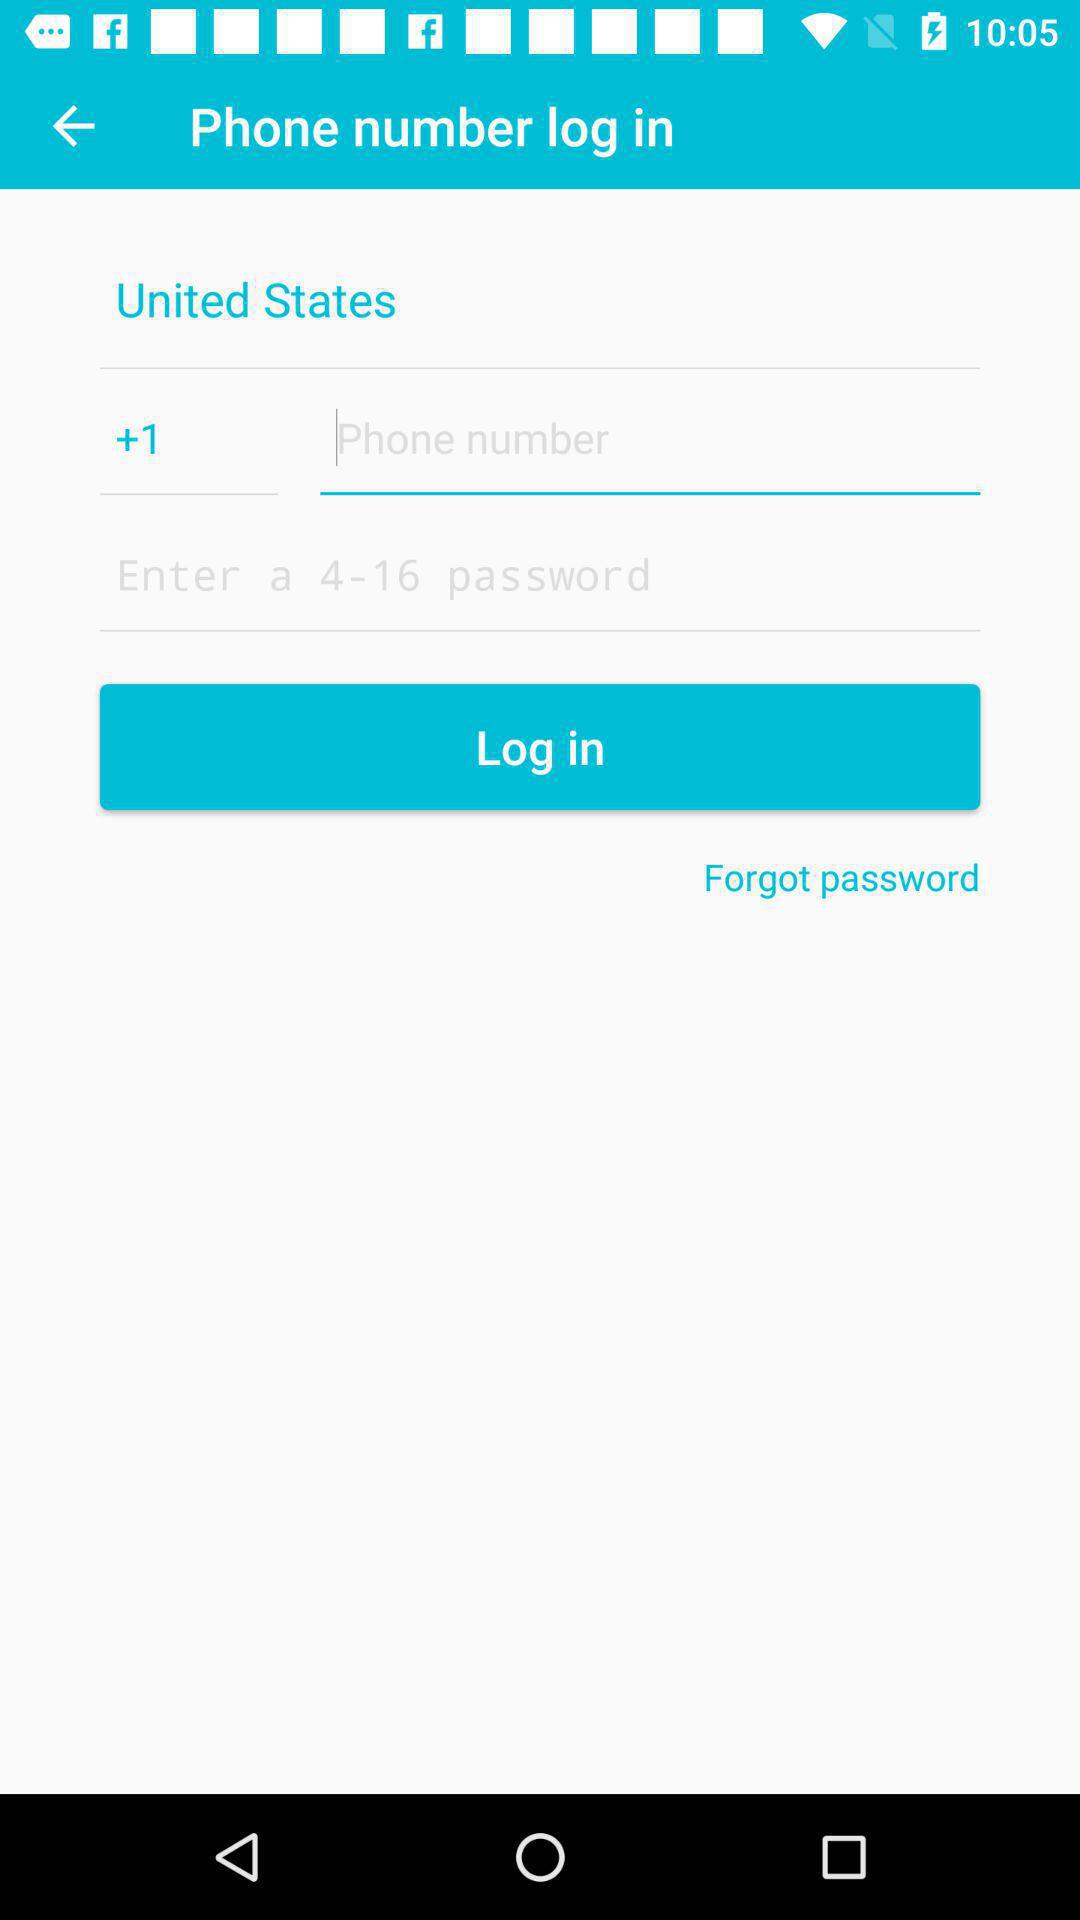How many text inputs are there for the phone number?
Answer the question using a single word or phrase. 2 